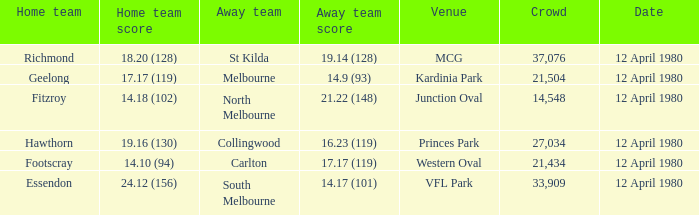At which location did fitzroy perform as the home team? Junction Oval. 